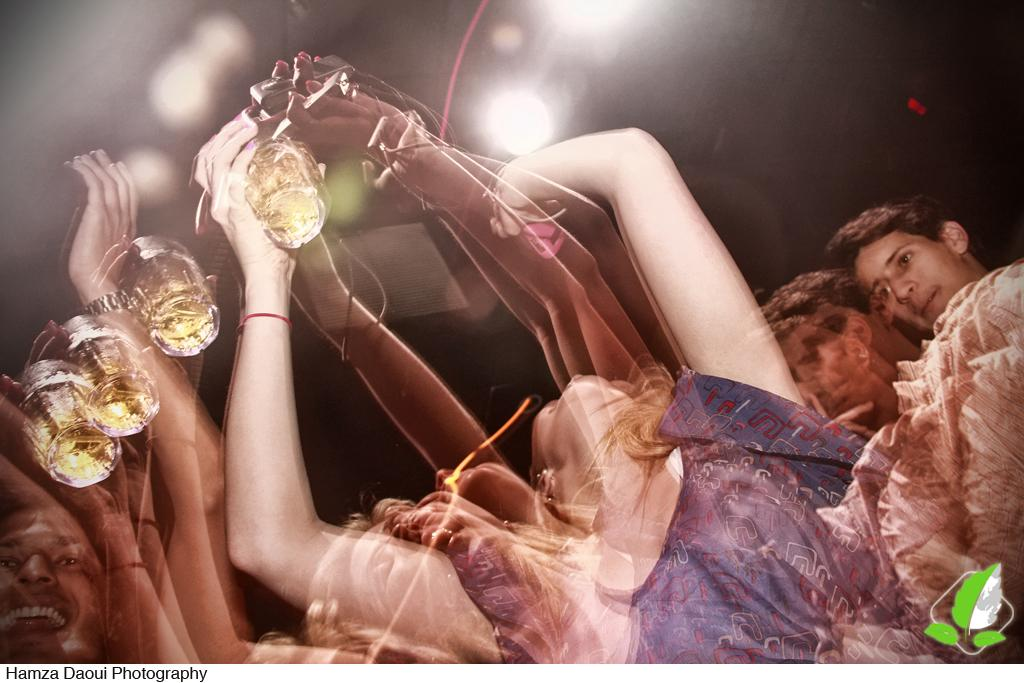Who or what is present in the image? There are people in the image. What are the people doing in the image? The people are standing in the image. What objects are the people holding in their hands? The people are holding wine glasses in their hands. What can be seen at the top of the image? There are lights visible at the top of the image. What type of paste is being used to stick the rice on the wall in the image? There is no paste or rice present in the image; it features people holding wine glasses and lights visible at the top. 